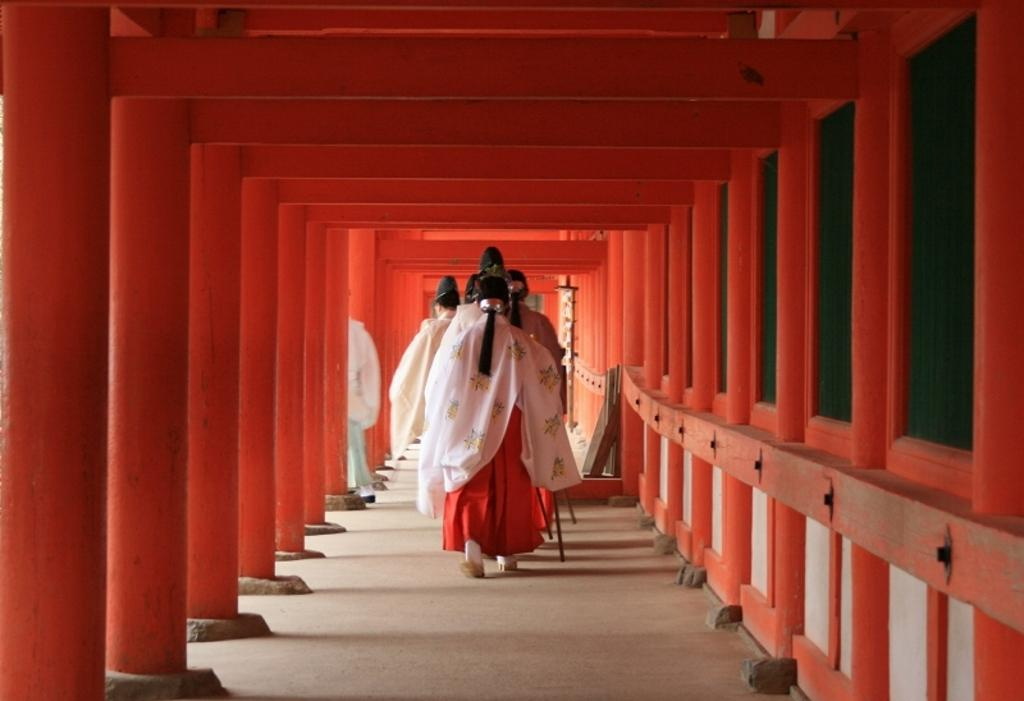What are the people in the image doing? There are many people walking in the image. What can be seen at the bottom of the image? There is a floor visible at the bottom of the image. What architectural feature is present on the left side of the image? There are pillars to the left of the image. What type of comb is being used by the person in the image? There is no comb present in the image. What type of quill is being held by the person in the image? There is no quill present in the image. What type of beef is being served in the image? There is no beef present in the image. 